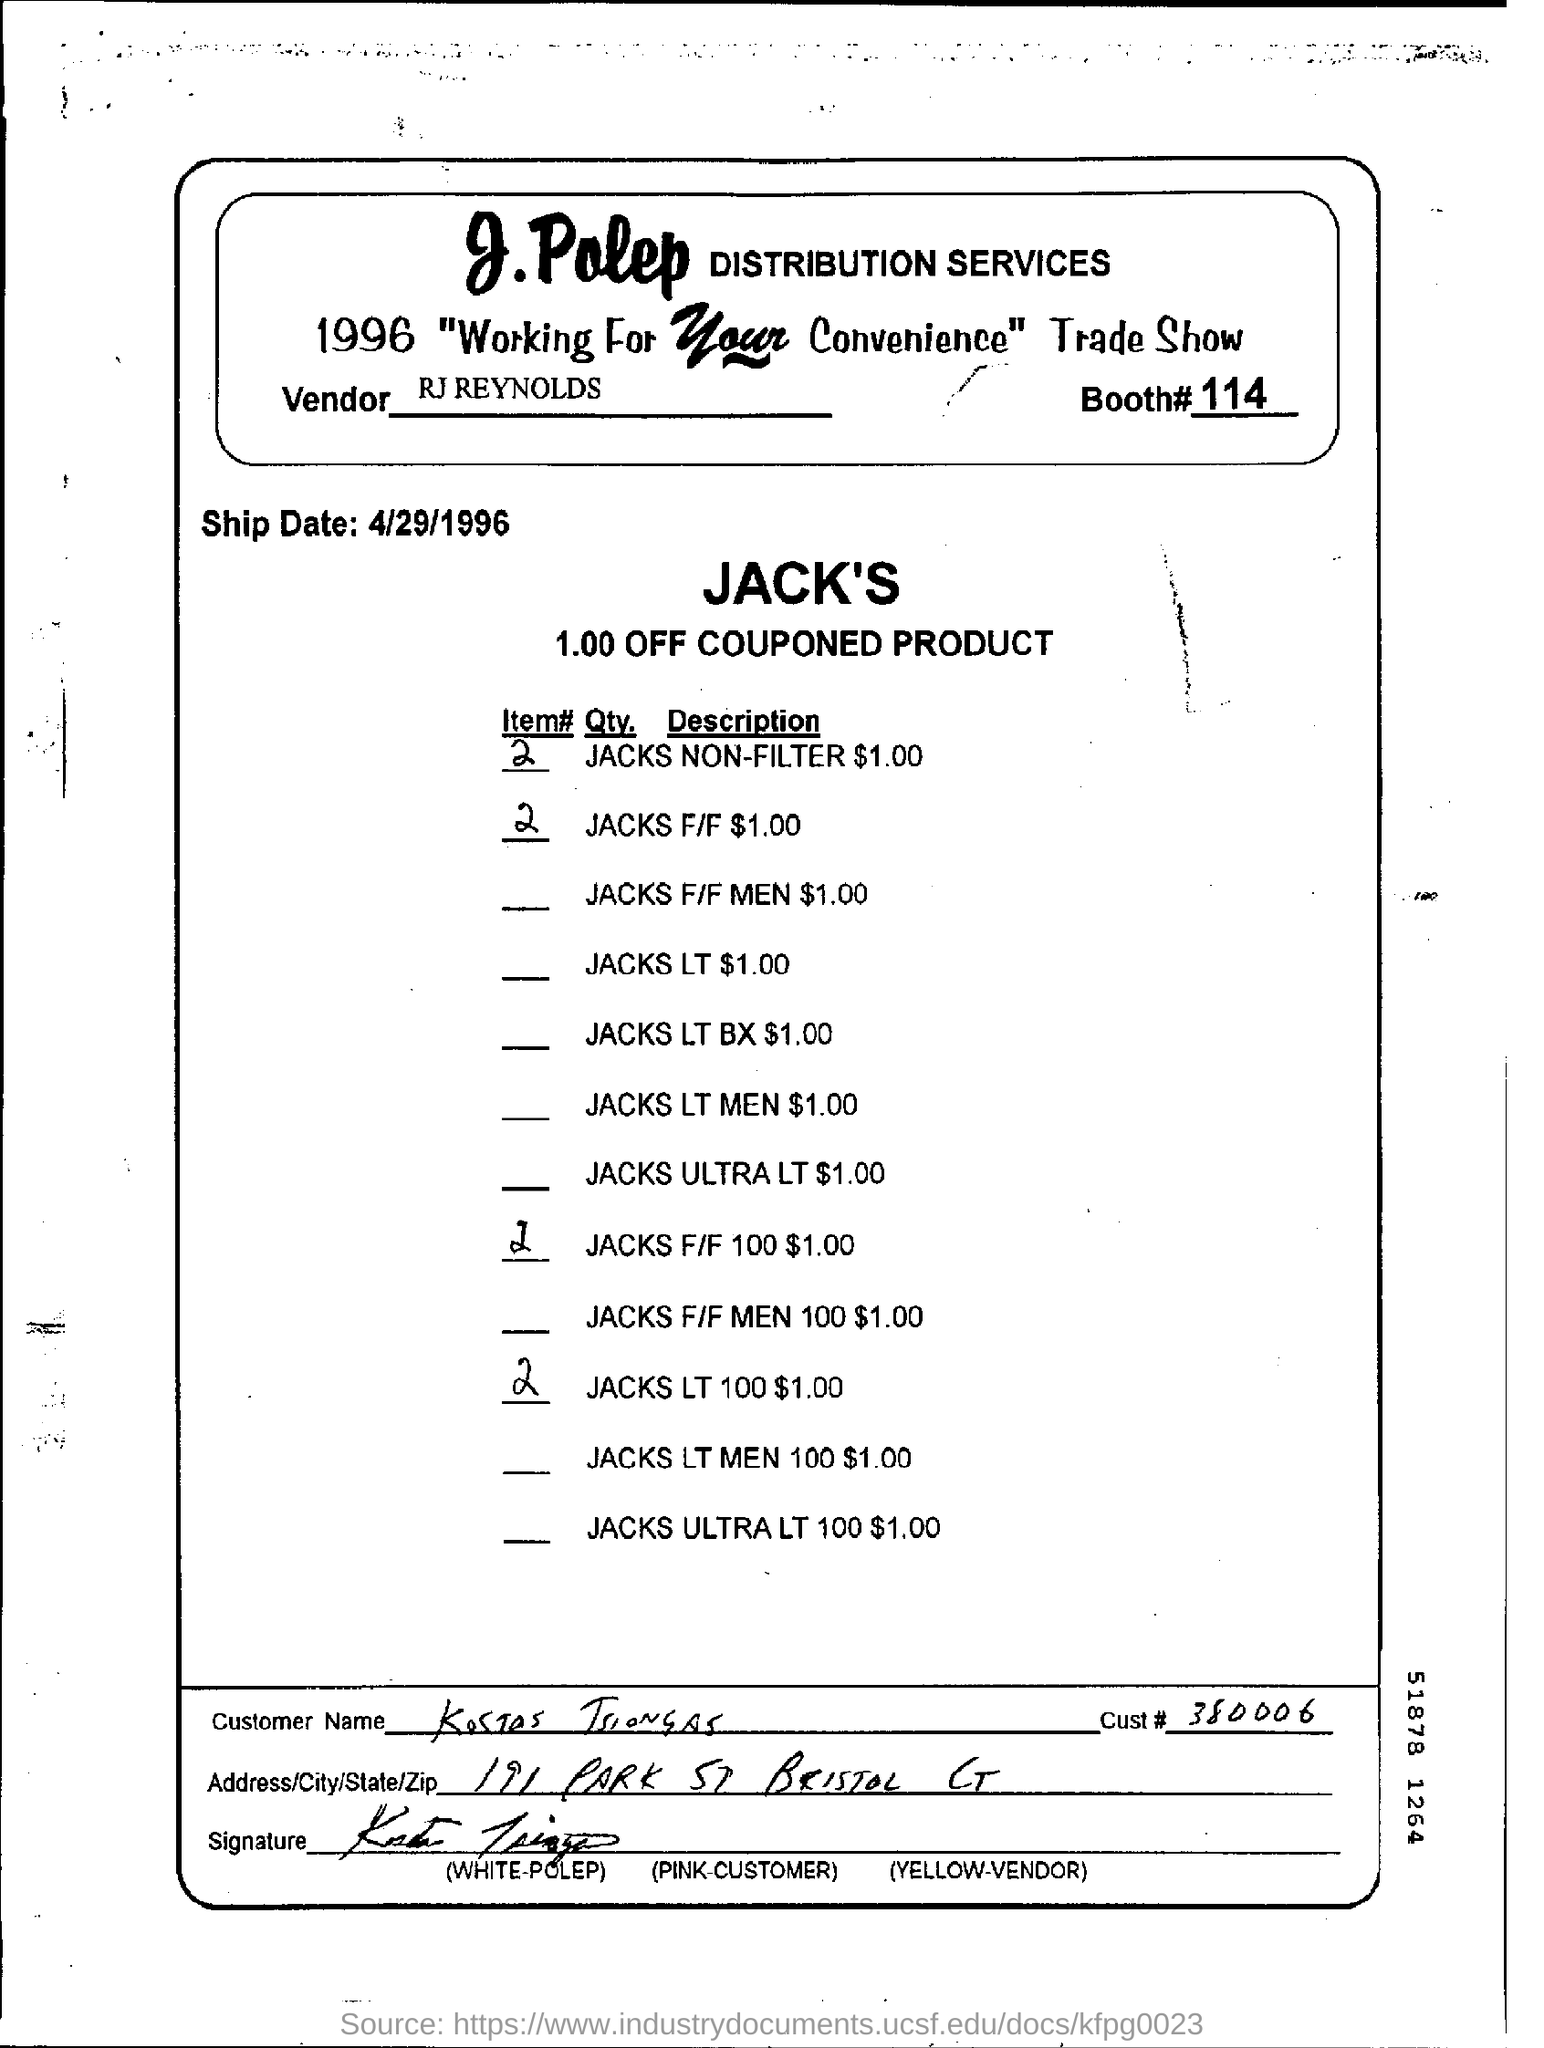Point out several critical features in this image. The name of the distribution service is J.Polep. I would like to know the cust number. Specifically, it is 380006... The item number of JACKS for a female size F/F is $1.00. The booth number is 114. The ship date is 4/29/1996. 